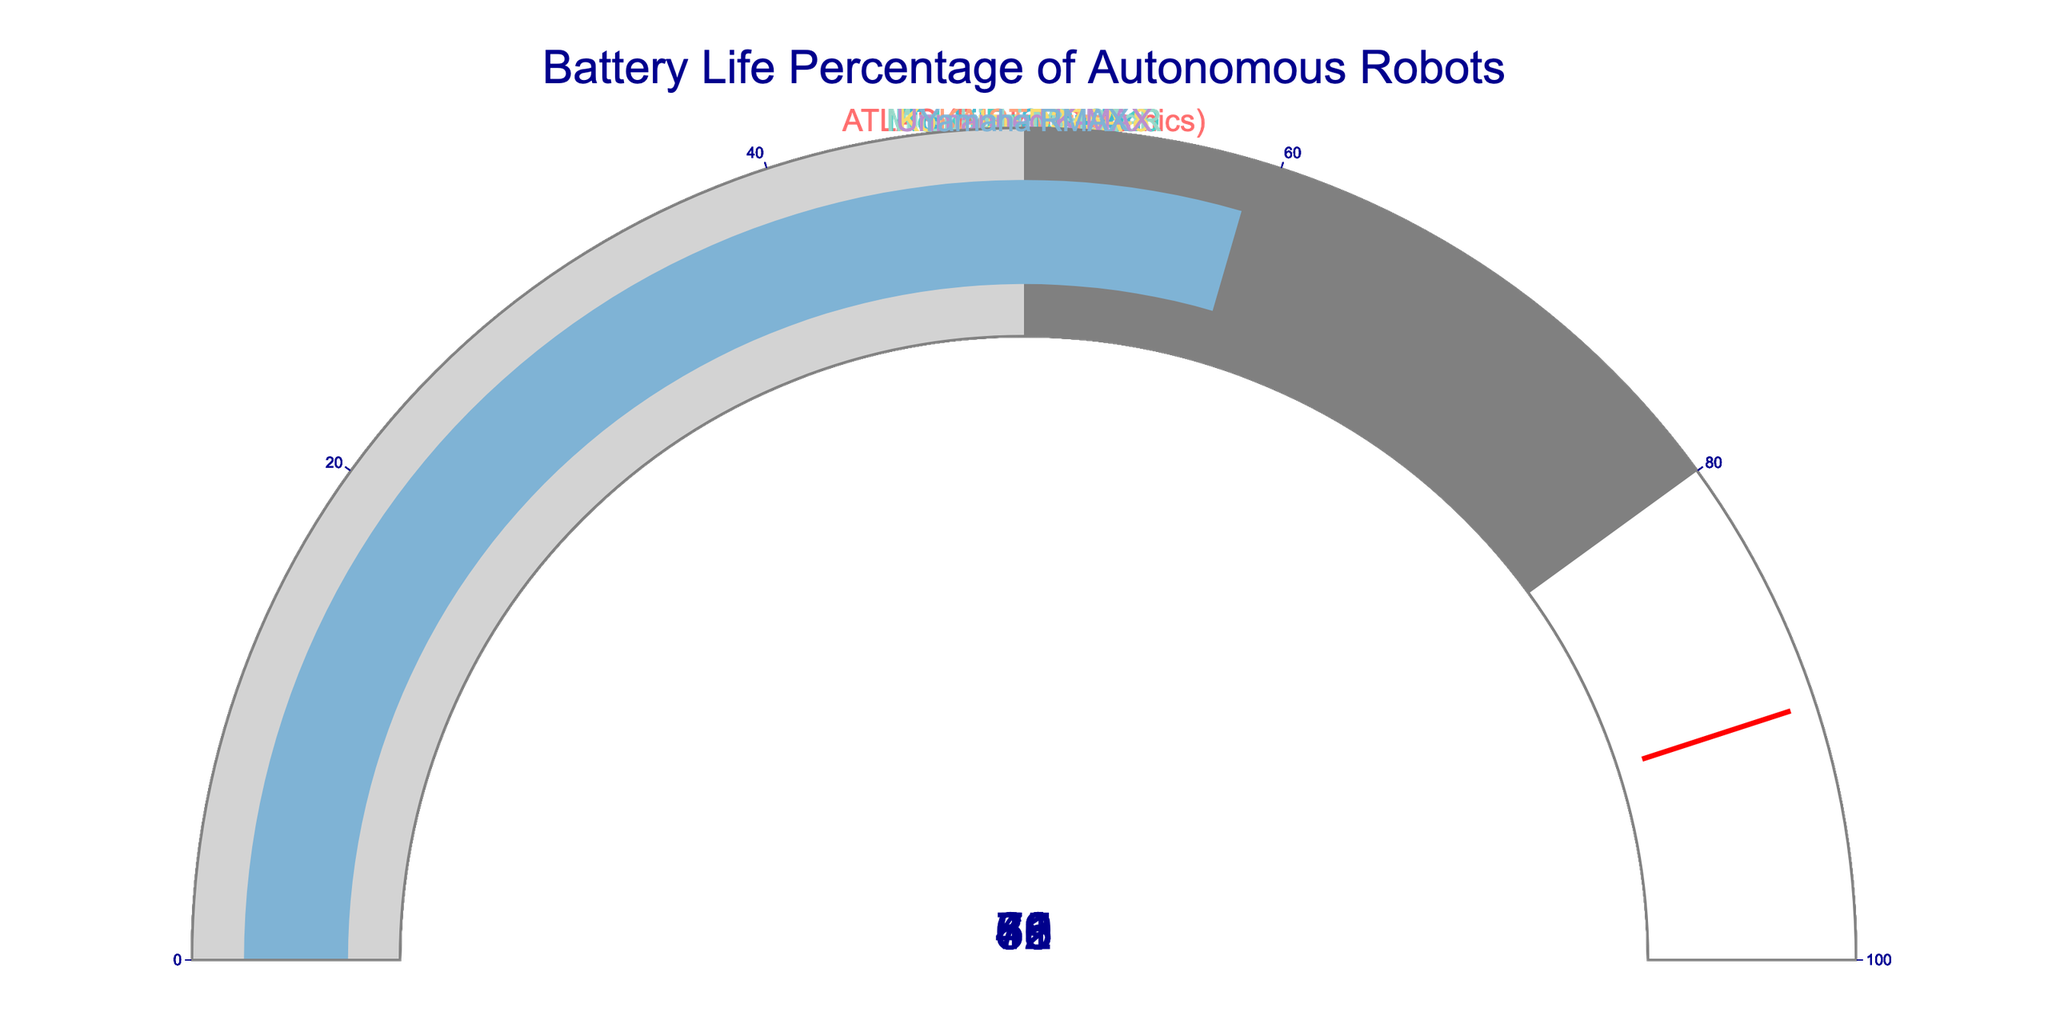What's the title of the figure? The title of the figure is placed prominently at the top of the image and usually stands out due to its larger font size.
Answer: Battery Life Percentage of Autonomous Robots How many robot models are displayed in the figure? Each gauge represents one robot model, and we can count the total number of gauges present in the figure.
Answer: Eight What's the battery life percentage of the KAIST Hubo robot? Look for the gauge that corresponds to the KAIST Hubo robot and read the numerical value displayed on it.
Answer: 83 Which robot has the highest battery life percentage? Compare the battery life percentages shown on each gauge and identify the robot with the highest value.
Answer: KAIST Hubo Which robot has the lowest battery life percentage? Compare the battery life percentages shown on each gauge and identify the robot with the lowest value.
Answer: Toshiba Scorpion What is the average battery life percentage for all the robots displayed? Sum the battery life percentages of all eight robots and divide by the number of robots (8). (78 + 62 + 45 + 83 + 71 + 56 + 68 + 59) / 8 = 522 / 8
Answer: 65.25 How many robots have a battery life percentage greater than 70? Count the number of gauges that display a battery life percentage greater than 70.
Answer: Three (ATLAS, KAIST Hubo, Mitsubishi MEISTeR) If the threshold value is set at 90%, how many robots are below this threshold? All gauges have a threshold indicator at 90%. Count all the robots with battery life percentages below this value.
Answer: All eight robots Which two robots have the most similar battery life percentages? Compare the battery life percentages of all the robots and identify the two with the closest values.
Answer: Unmanned K-MAX and iRobot PackBot 510 (68 and 62) What is the range of battery life percentages displayed in the figure? Identify the highest and lowest battery life percentages and calculate the range by subtracting the lowest value from the highest. 83 (highest) - 45 (lowest) = 38
Answer: 38 